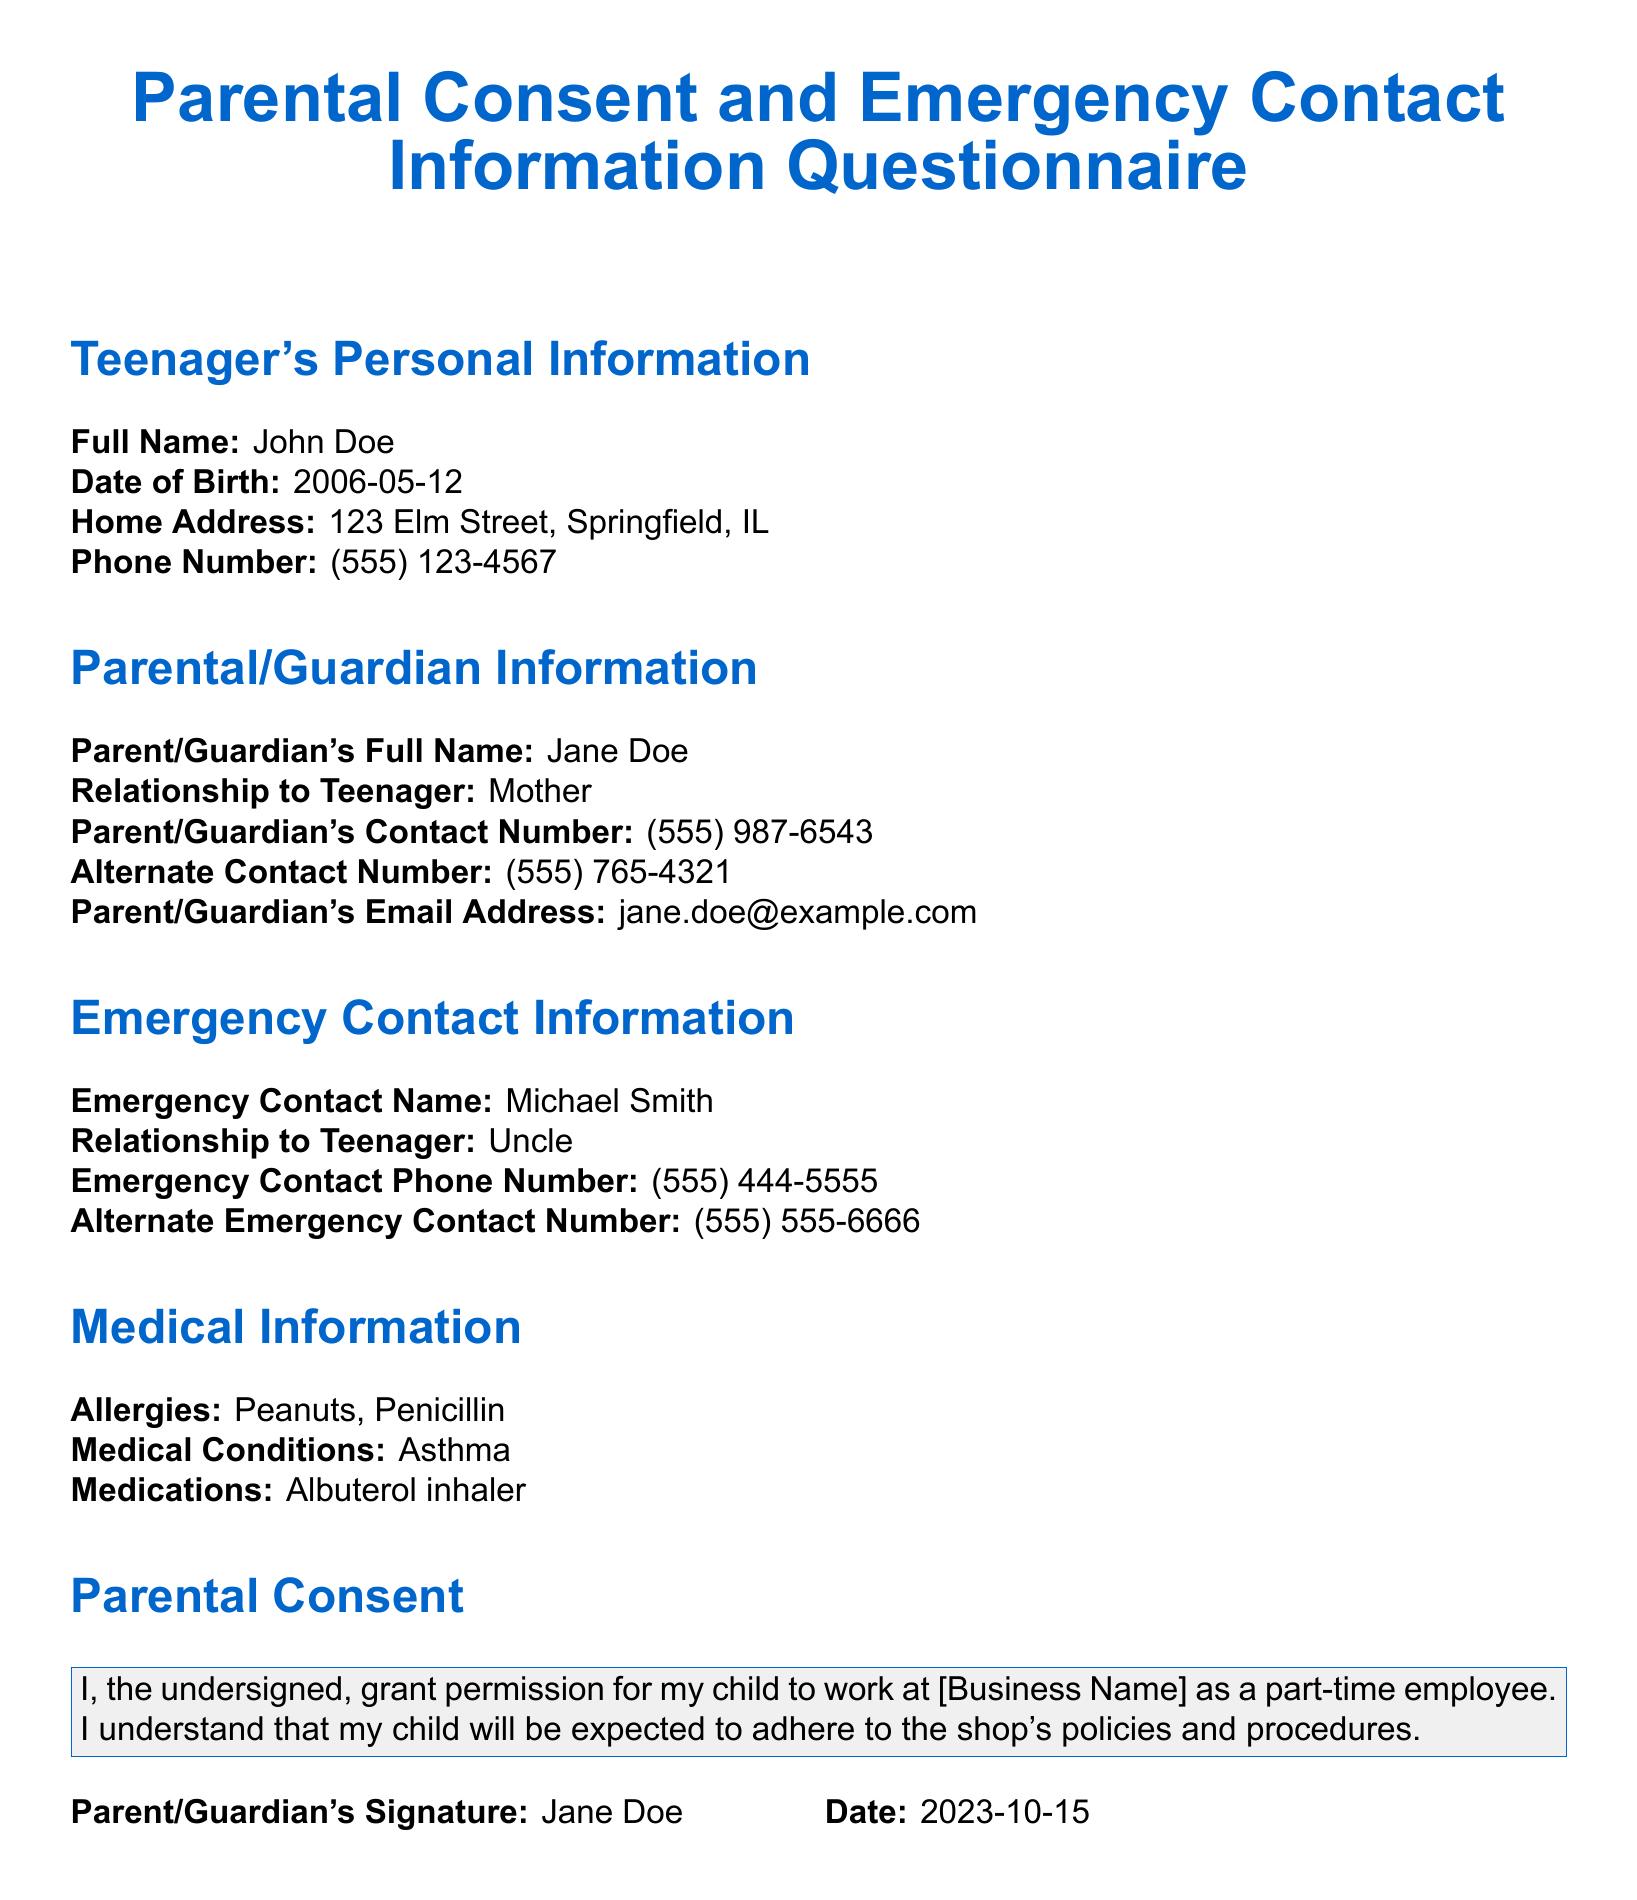What is the teenager's full name? The full name of the teenager is stated in the personal information section of the document.
Answer: John Doe What is the date of birth? The teenager's date of birth can be found in the personal information section of the document.
Answer: 2006-05-12 Who is the parent/guardian? The name of the parent or guardian is specified in the parental/guardian information section.
Answer: Jane Doe What is the relationship of the emergency contact to the teenager? The relationship of the emergency contact is mentioned in the emergency contact information section.
Answer: Uncle What allergies does the teenager have? The allergies of the teenager are listed in the medical information section.
Answer: Peanuts, Penicillin What is the parent's contact number? The parent's contact number is provided in the parental/guardian information section of the document.
Answer: (555) 987-6543 What is required for the teenager to work at the business? This requirement is mentioned in the parental consent statement within the document.
Answer: Permission from parent/guardian What date is the parental consent form signed? The document states the date the parental consent form was signed.
Answer: 2023-10-15 How many emergency contact numbers are listed? The number of emergency contact numbers can be counted in the emergency contact information section.
Answer: Two 